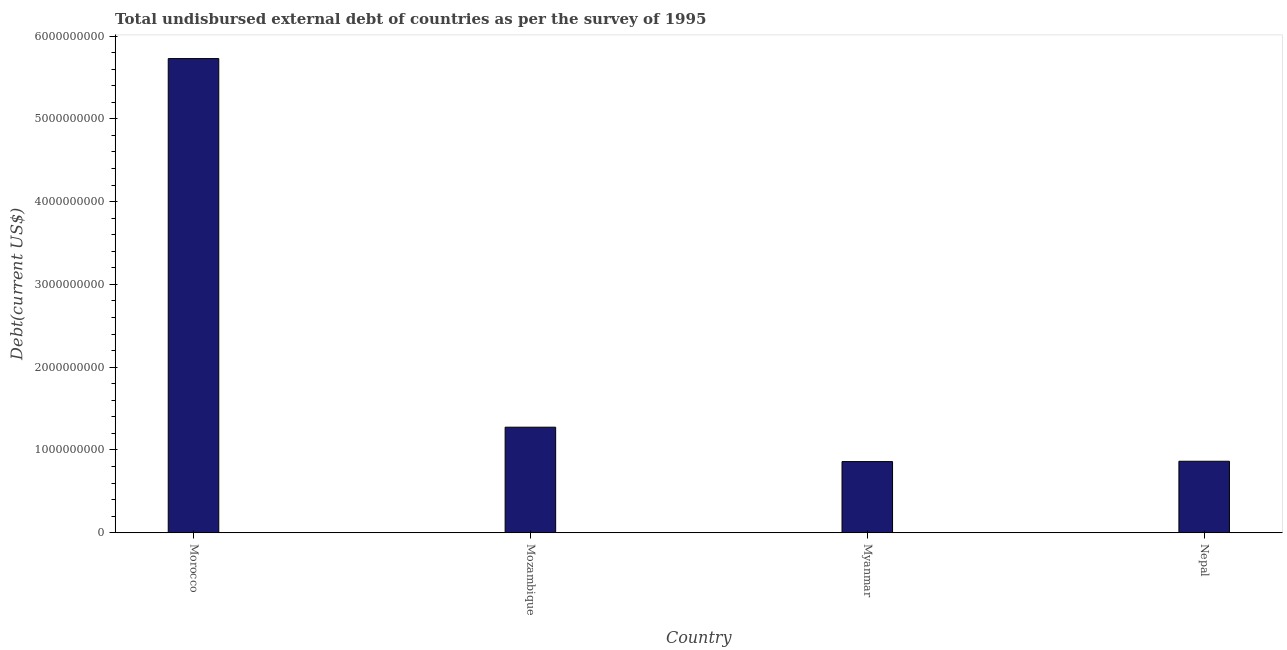Does the graph contain any zero values?
Make the answer very short. No. What is the title of the graph?
Your response must be concise. Total undisbursed external debt of countries as per the survey of 1995. What is the label or title of the Y-axis?
Offer a very short reply. Debt(current US$). What is the total debt in Myanmar?
Keep it short and to the point. 8.59e+08. Across all countries, what is the maximum total debt?
Give a very brief answer. 5.73e+09. Across all countries, what is the minimum total debt?
Your answer should be compact. 8.59e+08. In which country was the total debt maximum?
Provide a short and direct response. Morocco. In which country was the total debt minimum?
Make the answer very short. Myanmar. What is the sum of the total debt?
Keep it short and to the point. 8.72e+09. What is the difference between the total debt in Morocco and Myanmar?
Offer a very short reply. 4.87e+09. What is the average total debt per country?
Your answer should be compact. 2.18e+09. What is the median total debt?
Give a very brief answer. 1.07e+09. What is the ratio of the total debt in Morocco to that in Mozambique?
Ensure brevity in your answer.  4.49. What is the difference between the highest and the second highest total debt?
Your response must be concise. 4.45e+09. Is the sum of the total debt in Mozambique and Nepal greater than the maximum total debt across all countries?
Provide a succinct answer. No. What is the difference between the highest and the lowest total debt?
Provide a short and direct response. 4.87e+09. Are the values on the major ticks of Y-axis written in scientific E-notation?
Your response must be concise. No. What is the Debt(current US$) of Morocco?
Your response must be concise. 5.73e+09. What is the Debt(current US$) of Mozambique?
Keep it short and to the point. 1.27e+09. What is the Debt(current US$) in Myanmar?
Offer a very short reply. 8.59e+08. What is the Debt(current US$) in Nepal?
Ensure brevity in your answer.  8.63e+08. What is the difference between the Debt(current US$) in Morocco and Mozambique?
Provide a succinct answer. 4.45e+09. What is the difference between the Debt(current US$) in Morocco and Myanmar?
Make the answer very short. 4.87e+09. What is the difference between the Debt(current US$) in Morocco and Nepal?
Give a very brief answer. 4.86e+09. What is the difference between the Debt(current US$) in Mozambique and Myanmar?
Offer a terse response. 4.15e+08. What is the difference between the Debt(current US$) in Mozambique and Nepal?
Keep it short and to the point. 4.12e+08. What is the difference between the Debt(current US$) in Myanmar and Nepal?
Offer a terse response. -3.81e+06. What is the ratio of the Debt(current US$) in Morocco to that in Mozambique?
Give a very brief answer. 4.49. What is the ratio of the Debt(current US$) in Morocco to that in Myanmar?
Make the answer very short. 6.67. What is the ratio of the Debt(current US$) in Morocco to that in Nepal?
Give a very brief answer. 6.64. What is the ratio of the Debt(current US$) in Mozambique to that in Myanmar?
Your answer should be compact. 1.48. What is the ratio of the Debt(current US$) in Mozambique to that in Nepal?
Give a very brief answer. 1.48. What is the ratio of the Debt(current US$) in Myanmar to that in Nepal?
Give a very brief answer. 1. 